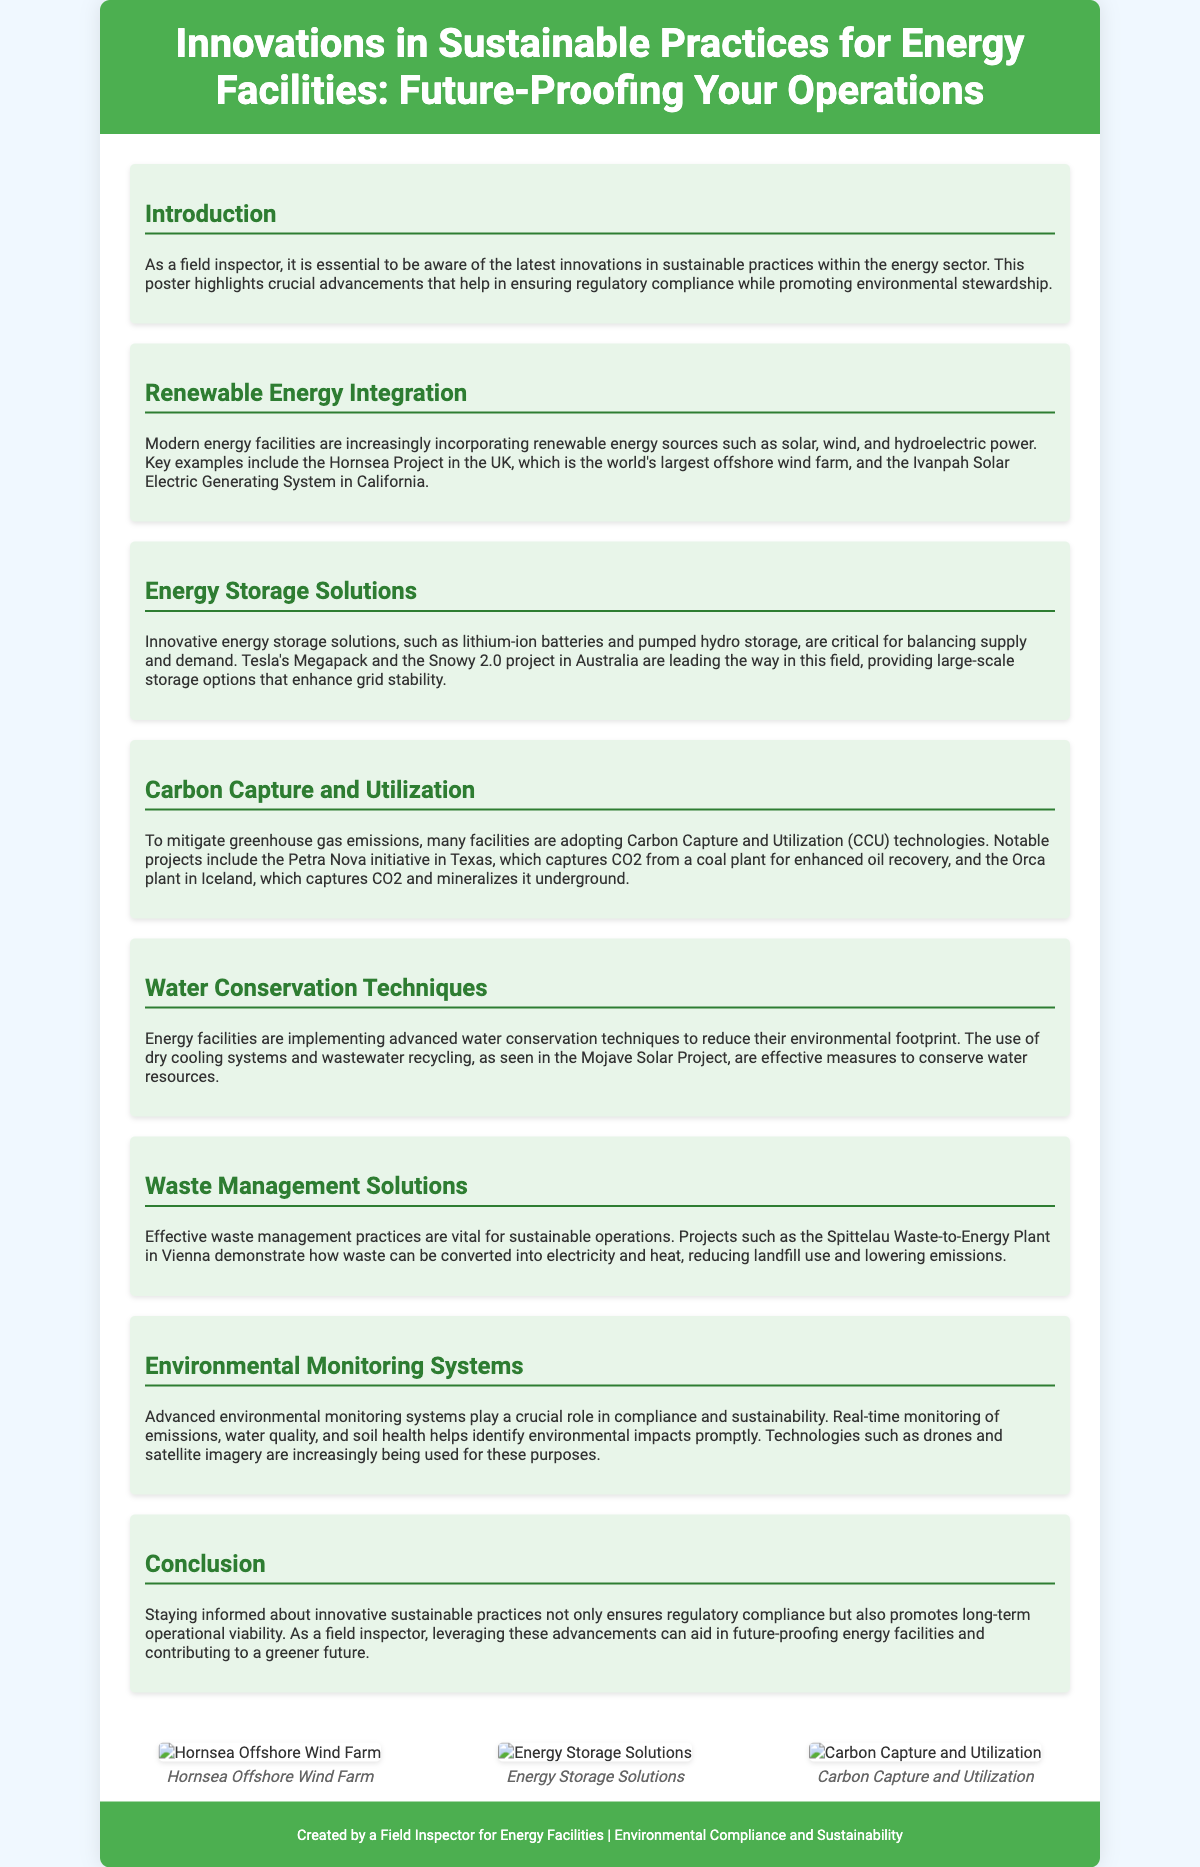what is the title of the poster? The title is prominently displayed at the top of the poster, stating the focus on innovations for energy facilities.
Answer: Innovations in Sustainable Practices for Energy Facilities: Future-Proofing Your Operations which renewable energy source is mentioned in the document? The document lists solar, wind, and hydroelectric power as examples of renewable energy sources being integrated into facilities.
Answer: Solar, wind, hydroelectric power what is the name of the world's largest offshore wind farm? The document provides a specific example of an offshore wind farm that is recognized for its size.
Answer: Hornsea Project which technology is used for energy storage according to the document? The document mentions several technologies involved in energy storage, including notable products and projects.
Answer: Lithium-ion batteries where is the Petra Nova project located? The document specifies the location of the Petra Nova initiative related to carbon capture technology.
Answer: Texas what is one of the advanced water conservation techniques mentioned? A specific technique implemented in energy facilities for water conservation is mentioned in the document.
Answer: Dry cooling systems which method does the Spittelau Waste-to-Energy Plant use? The document discusses how waste is converted into usable energy at this particular facility.
Answer: Waste-to-energy conversion what role do advanced environmental monitoring systems play? The document highlights the importance of these systems in monitoring specific environmental factors.
Answer: Compliance and sustainability what is a benefit of incorporating renewable energy in energy facilities? The document outlines how renewable energy integration helps firms promote environmental stewardship.
Answer: Environmental stewardship 